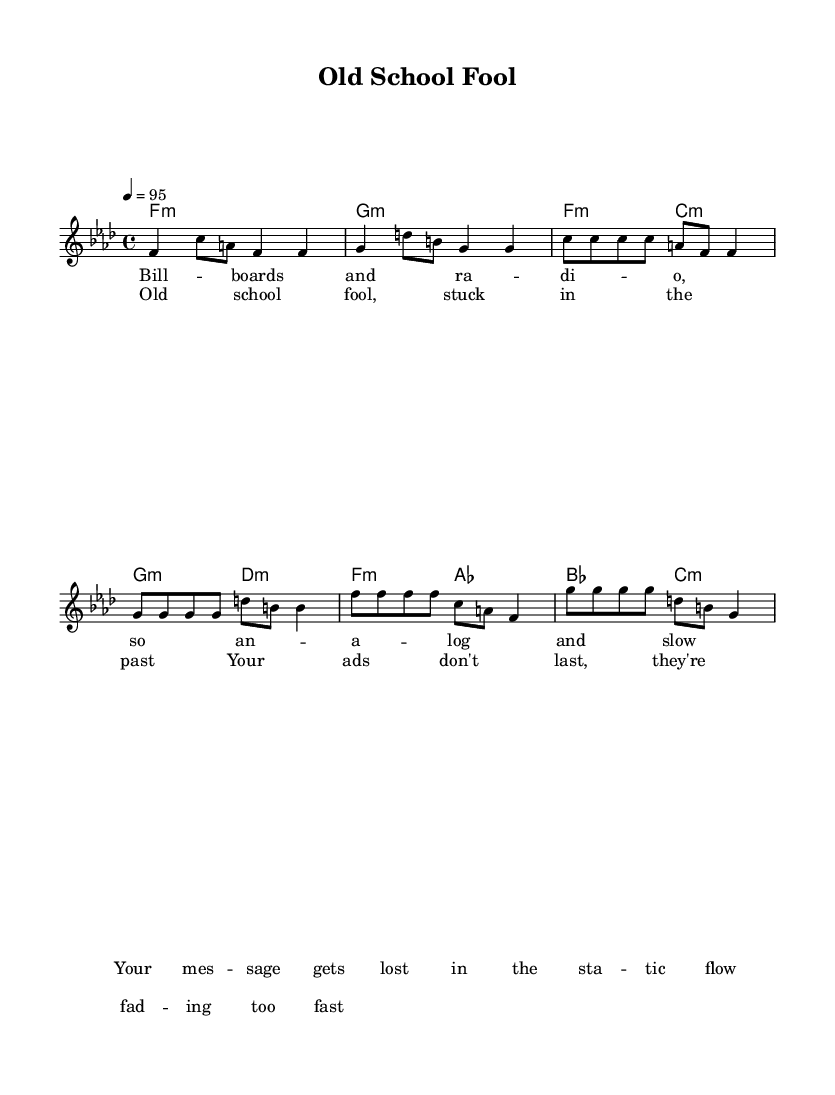What is the key signature of this music? The key signature is F minor, indicated by the presence of four flats in the key signature that is displayed at the beginning of the sheet music.
Answer: F minor What is the time signature of this music? The time signature is 4/4, which is indicated at the beginning of the sheet music, showing that there are four beats per measure and a quarter note receives one beat.
Answer: 4/4 What is the tempo marking for this piece? The tempo marking is 4 = 95, which means that there are 95 beats per minute with each quarter note receiving one beat. This tempo is specified right before the melody section.
Answer: 95 What are the first two words of the verse lyrics? The first two words of the verse lyrics are "Bill boards," which are written out in the lyric section of the score, corresponding to the first notes of the melody.
Answer: Bill boards How many measures are in the chorus? There are four measures in the chorus section, which can be counted by looking at the number of measures listed in the melody part where the chorus lyrics start.
Answer: 4 What do the lyrics in the chorus imply about traditional advertising? The lyrics express criticism of traditional advertising methods, stating "Your ads don't last, they're fading too fast," which suggests that the effectiveness of conventional ads is diminishing.
Answer: Criticism What type of chord is used in the introduction? The chords used in the introduction are minor chords, as indicated by the use of "m" next to each chord designation in the harmony section.
Answer: Minor 